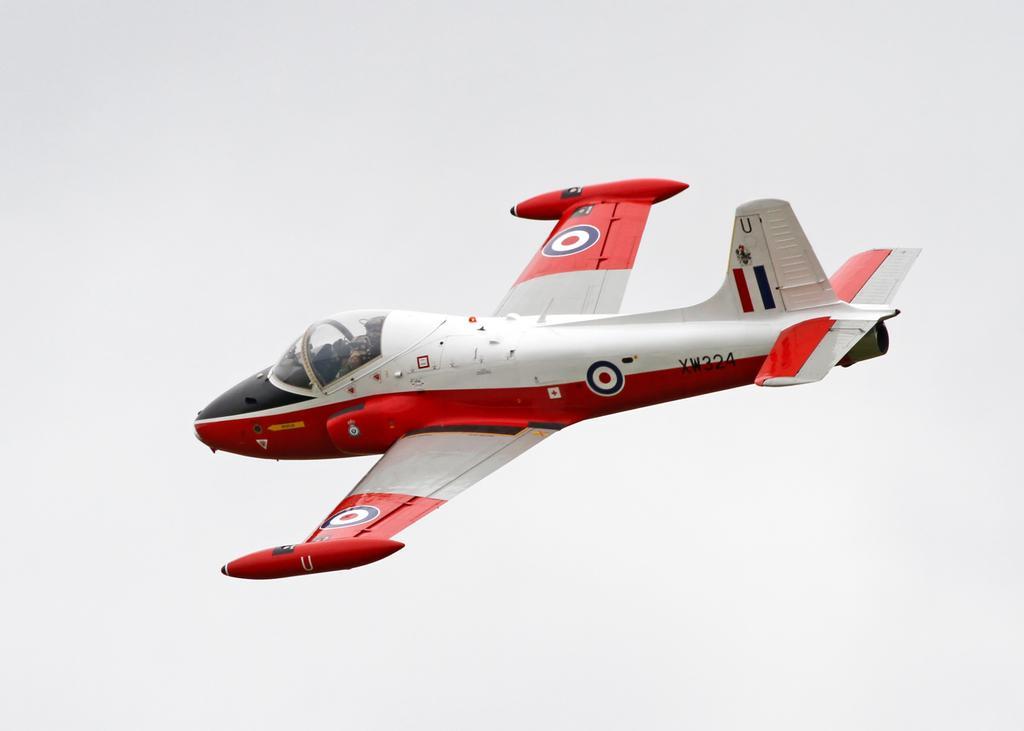Describe this image in one or two sentences. In this image we can see an airplane flying and in the background, we can see the sky. 